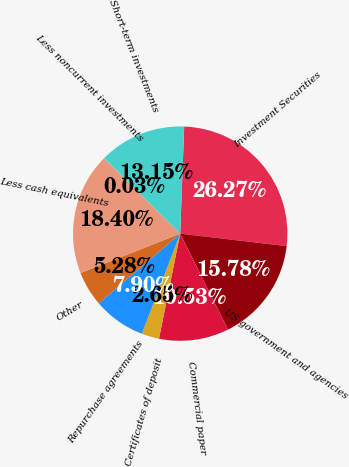Convert chart to OTSL. <chart><loc_0><loc_0><loc_500><loc_500><pie_chart><fcel>Investment Securities<fcel>US government and agencies<fcel>Commercial paper<fcel>Certificates of deposit<fcel>Repurchase agreements<fcel>Other<fcel>Less cash equivalents<fcel>Less noncurrent investments<fcel>Short-term investments<nl><fcel>26.27%<fcel>15.78%<fcel>10.53%<fcel>2.65%<fcel>7.9%<fcel>5.28%<fcel>18.4%<fcel>0.03%<fcel>13.15%<nl></chart> 